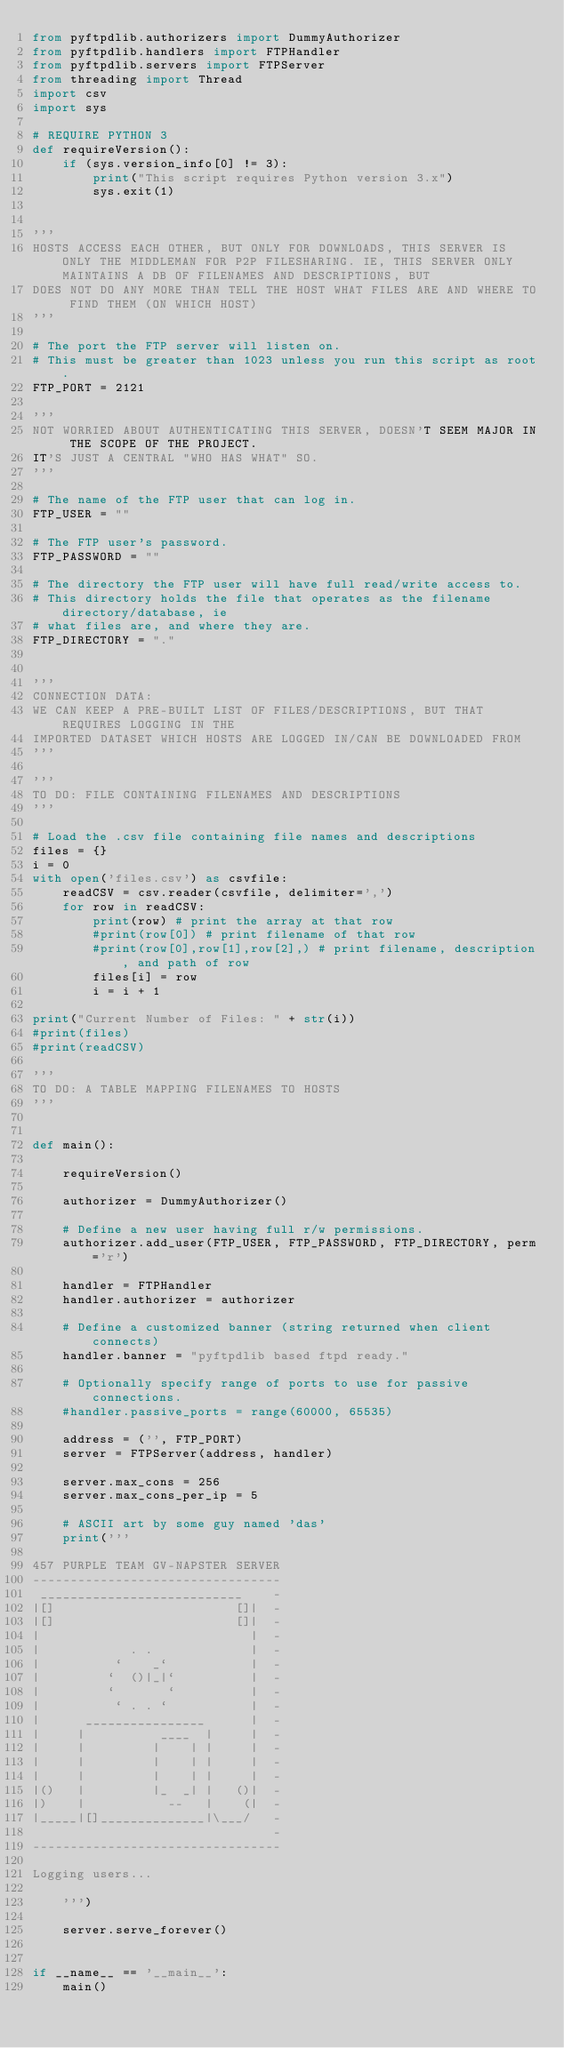Convert code to text. <code><loc_0><loc_0><loc_500><loc_500><_Python_>from pyftpdlib.authorizers import DummyAuthorizer
from pyftpdlib.handlers import FTPHandler
from pyftpdlib.servers import FTPServer
from threading import Thread
import csv
import sys

# REQUIRE PYTHON 3
def requireVersion():
    if (sys.version_info[0] != 3):
        print("This script requires Python version 3.x")
        sys.exit(1)


'''
HOSTS ACCESS EACH OTHER, BUT ONLY FOR DOWNLOADS, THIS SERVER IS ONLY THE MIDDLEMAN FOR P2P FILESHARING. IE, THIS SERVER ONLY MAINTAINS A DB OF FILENAMES AND DESCRIPTIONS, BUT
DOES NOT DO ANY MORE THAN TELL THE HOST WHAT FILES ARE AND WHERE TO FIND THEM (ON WHICH HOST)
'''

# The port the FTP server will listen on.
# This must be greater than 1023 unless you run this script as root.
FTP_PORT = 2121

'''
NOT WORRIED ABOUT AUTHENTICATING THIS SERVER, DOESN'T SEEM MAJOR IN THE SCOPE OF THE PROJECT.
IT'S JUST A CENTRAL "WHO HAS WHAT" SO. 
'''

# The name of the FTP user that can log in.
FTP_USER = ""

# The FTP user's password.
FTP_PASSWORD = ""

# The directory the FTP user will have full read/write access to.
# This directory holds the file that operates as the filename directory/database, ie
# what files are, and where they are. 
FTP_DIRECTORY = "."


'''
CONNECTION DATA:
WE CAN KEEP A PRE-BUILT LIST OF FILES/DESCRIPTIONS, BUT THAT REQUIRES LOGGING IN THE
IMPORTED DATASET WHICH HOSTS ARE LOGGED IN/CAN BE DOWNLOADED FROM
'''

'''
TO DO: FILE CONTAINING FILENAMES AND DESCRIPTIONS
'''

# Load the .csv file containing file names and descriptions
files = {}
i = 0
with open('files.csv') as csvfile:
    readCSV = csv.reader(csvfile, delimiter=',')
    for row in readCSV:
        print(row) # print the array at that row
        #print(row[0]) # print filename of that row
        #print(row[0],row[1],row[2],) # print filename, description, and path of row
        files[i] = row
        i = i + 1

print("Current Number of Files: " + str(i))
#print(files)
#print(readCSV)

'''
TO DO: A TABLE MAPPING FILENAMES TO HOSTS
'''


def main():

    requireVersion()

    authorizer = DummyAuthorizer()

    # Define a new user having full r/w permissions.
    authorizer.add_user(FTP_USER, FTP_PASSWORD, FTP_DIRECTORY, perm='r')

    handler = FTPHandler
    handler.authorizer = authorizer

    # Define a customized banner (string returned when client connects)
    handler.banner = "pyftpdlib based ftpd ready."

    # Optionally specify range of ports to use for passive connections.
    #handler.passive_ports = range(60000, 65535)

    address = ('', FTP_PORT)
    server = FTPServer(address, handler)

    server.max_cons = 256
    server.max_cons_per_ip = 5

    # ASCII art by some guy named 'das'
    print('''

457 PURPLE TEAM GV-NAPSTER SERVER
---------------------------------
 ___________________________    -
|[]                        []|  -
|[]                        []|  -
|                            |  -
|            . .             |  -
|          `    _`           |  -
|         `  ()|_|`          |  -
|         `       `          |  -
|          ` . . `           |  -
|      ________________      |  -
|     |          ____  |     |  -
|     |         |    | |     |  -
|     |         |    | |     |  -
|     |         |    | |     |  -
|()   |         |_  _| |   ()|  -
|)    |           --   |    (|  -
|_____|[]______________|\___/   -
                                -
---------------------------------

Logging users...

    ''')

    server.serve_forever()


if __name__ == '__main__':
    main()
</code> 